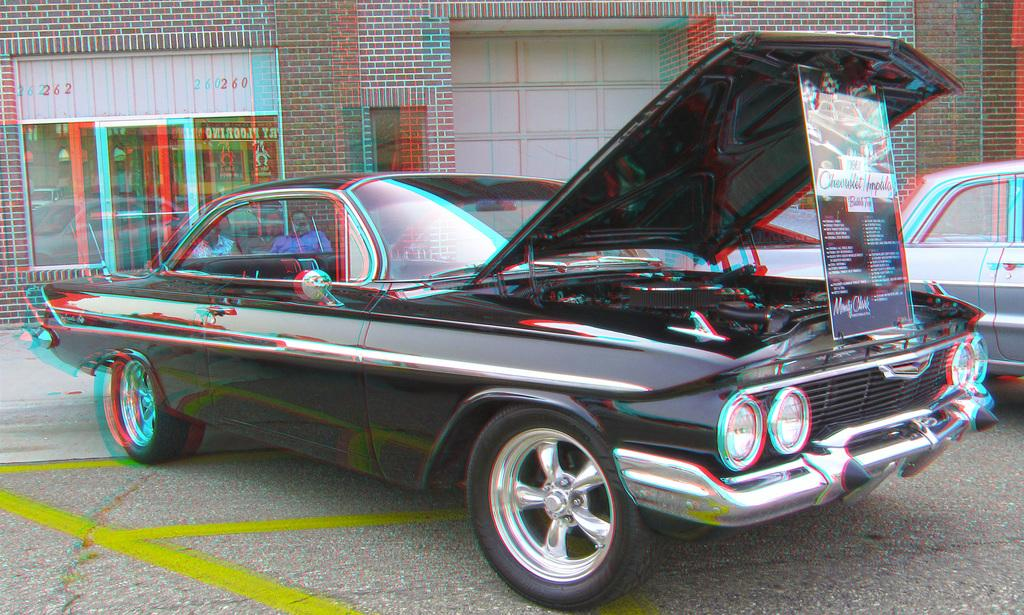What is the main subject in the center of the image? There are cars in the center of the image. What can be seen in the background of the image? There are buildings in the background of the image. What is located at the bottom of the image? There is a road at the bottom of the image. Where is the trail of jelly located in the image? There is no trail of jelly present in the image. Can you tell me how many parents are visible in the image? There are no parents visible in the image. 